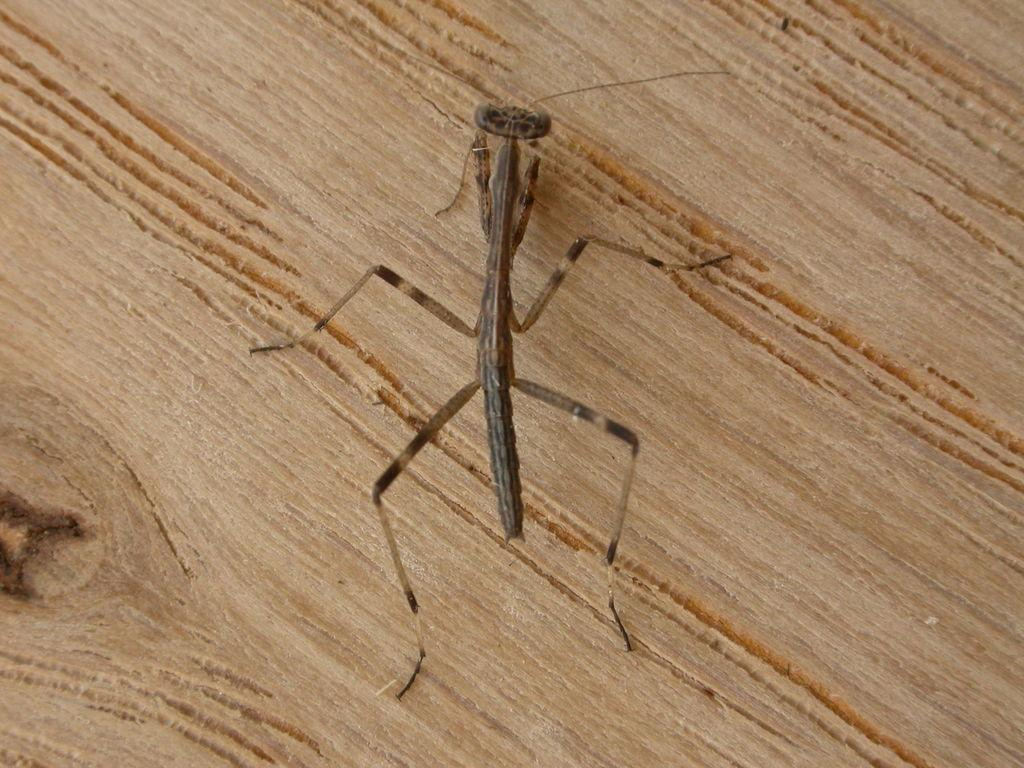What type of creature is in the image? There is an insect in the image. What surface is the insect on? The insect is on wood. How much does the sack weigh in the image? There is no sack present in the image, so it is not possible to determine its weight. 